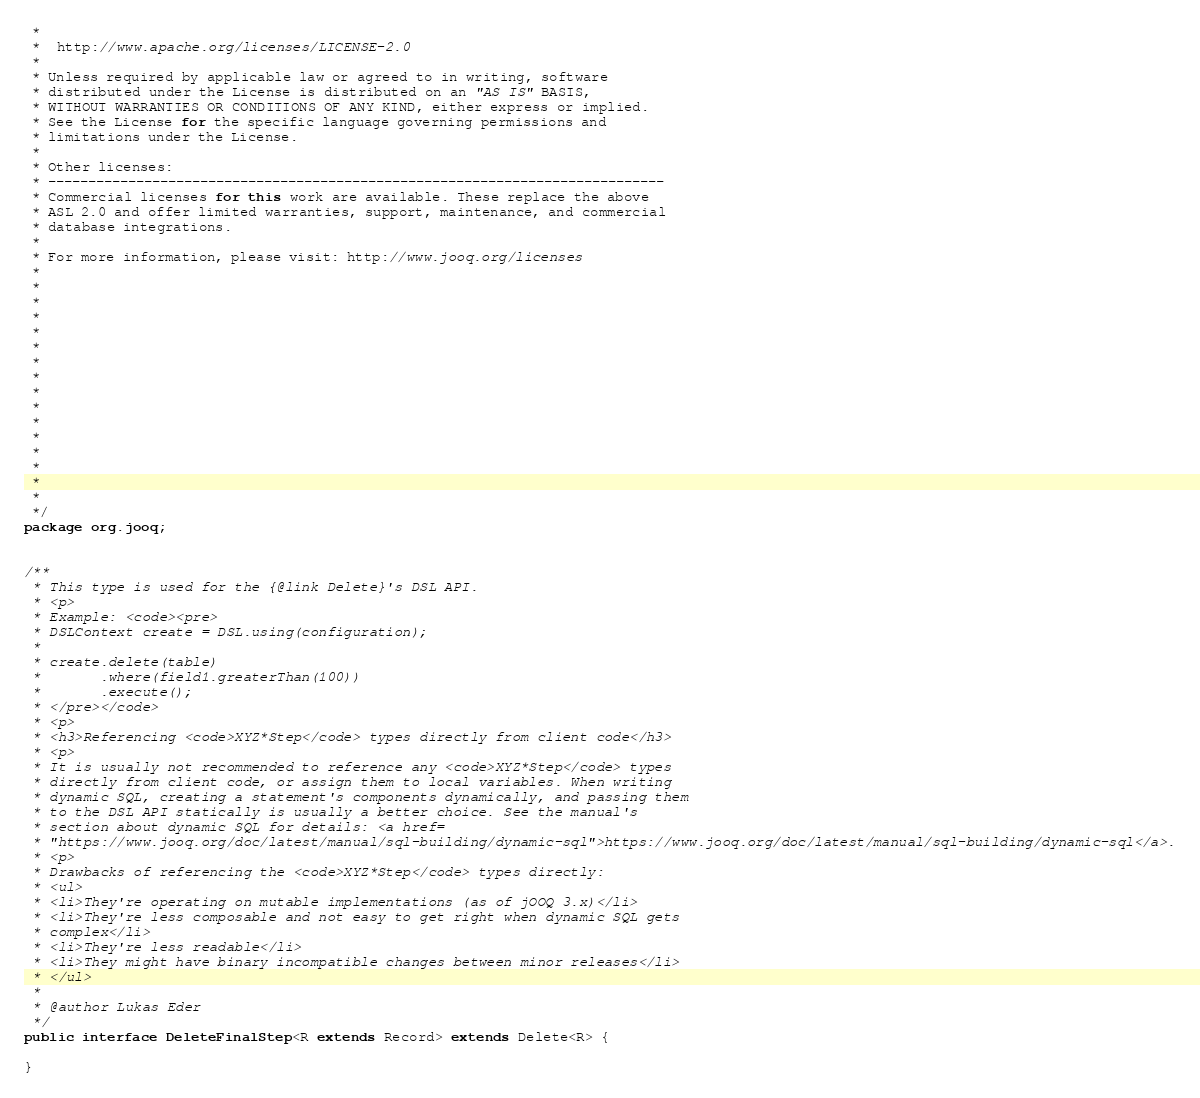Convert code to text. <code><loc_0><loc_0><loc_500><loc_500><_Java_> *
 *  http://www.apache.org/licenses/LICENSE-2.0
 *
 * Unless required by applicable law or agreed to in writing, software
 * distributed under the License is distributed on an "AS IS" BASIS,
 * WITHOUT WARRANTIES OR CONDITIONS OF ANY KIND, either express or implied.
 * See the License for the specific language governing permissions and
 * limitations under the License.
 *
 * Other licenses:
 * -----------------------------------------------------------------------------
 * Commercial licenses for this work are available. These replace the above
 * ASL 2.0 and offer limited warranties, support, maintenance, and commercial
 * database integrations.
 *
 * For more information, please visit: http://www.jooq.org/licenses
 *
 *
 *
 *
 *
 *
 *
 *
 *
 *
 *
 *
 *
 *
 *
 *
 */
package org.jooq;


/**
 * This type is used for the {@link Delete}'s DSL API.
 * <p>
 * Example: <code><pre>
 * DSLContext create = DSL.using(configuration);
 *
 * create.delete(table)
 *       .where(field1.greaterThan(100))
 *       .execute();
 * </pre></code>
 * <p>
 * <h3>Referencing <code>XYZ*Step</code> types directly from client code</h3>
 * <p>
 * It is usually not recommended to reference any <code>XYZ*Step</code> types
 * directly from client code, or assign them to local variables. When writing
 * dynamic SQL, creating a statement's components dynamically, and passing them
 * to the DSL API statically is usually a better choice. See the manual's
 * section about dynamic SQL for details: <a href=
 * "https://www.jooq.org/doc/latest/manual/sql-building/dynamic-sql">https://www.jooq.org/doc/latest/manual/sql-building/dynamic-sql</a>.
 * <p>
 * Drawbacks of referencing the <code>XYZ*Step</code> types directly:
 * <ul>
 * <li>They're operating on mutable implementations (as of jOOQ 3.x)</li>
 * <li>They're less composable and not easy to get right when dynamic SQL gets
 * complex</li>
 * <li>They're less readable</li>
 * <li>They might have binary incompatible changes between minor releases</li>
 * </ul>
 *
 * @author Lukas Eder
 */
public interface DeleteFinalStep<R extends Record> extends Delete<R> {

}
</code> 